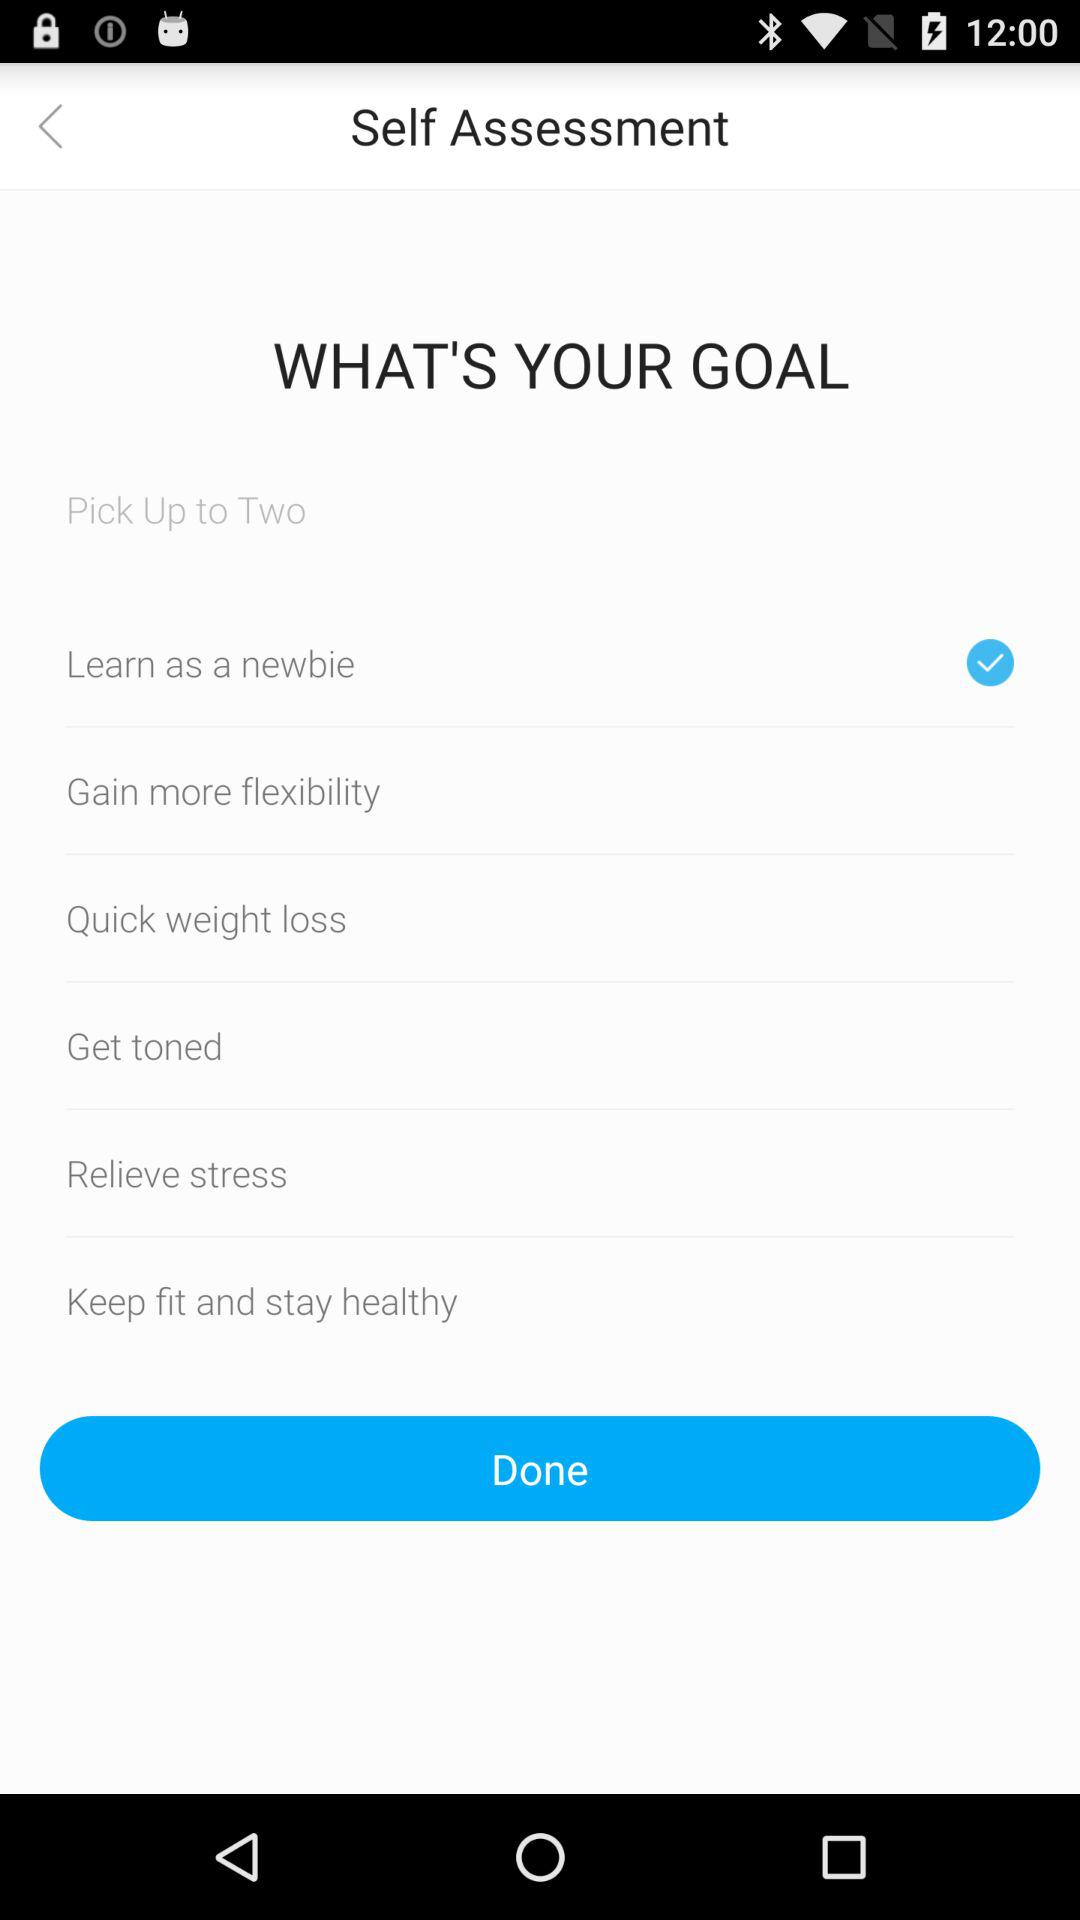Which option is the user's second goal?
When the provided information is insufficient, respond with <no answer>. <no answer> 